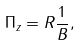Convert formula to latex. <formula><loc_0><loc_0><loc_500><loc_500>\Pi _ { z } = R \frac { 1 } { B } ,</formula> 